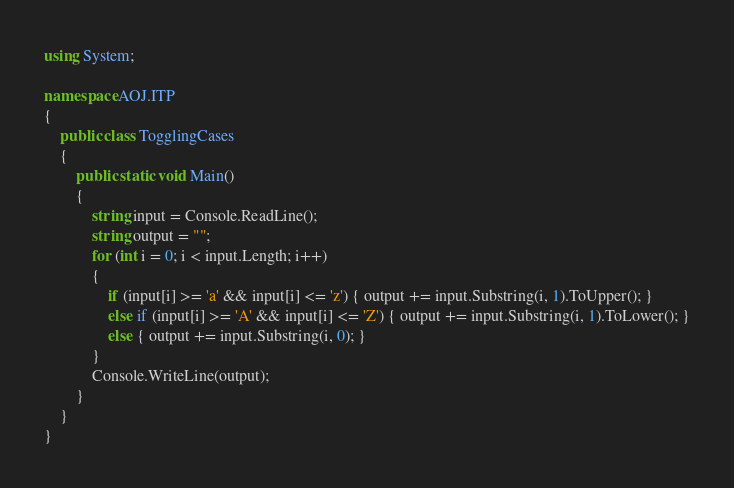Convert code to text. <code><loc_0><loc_0><loc_500><loc_500><_C#_>using System;

namespace AOJ.ITP
{
    public class TogglingCases
    {
        public static void Main()
        {
            string input = Console.ReadLine();
            string output = "";
            for (int i = 0; i < input.Length; i++)
            {
                if (input[i] >= 'a' && input[i] <= 'z') { output += input.Substring(i, 1).ToUpper(); }
                else if (input[i] >= 'A' && input[i] <= 'Z') { output += input.Substring(i, 1).ToLower(); }
                else { output += input.Substring(i, 0); }
            }
            Console.WriteLine(output);
        }
    }
}</code> 